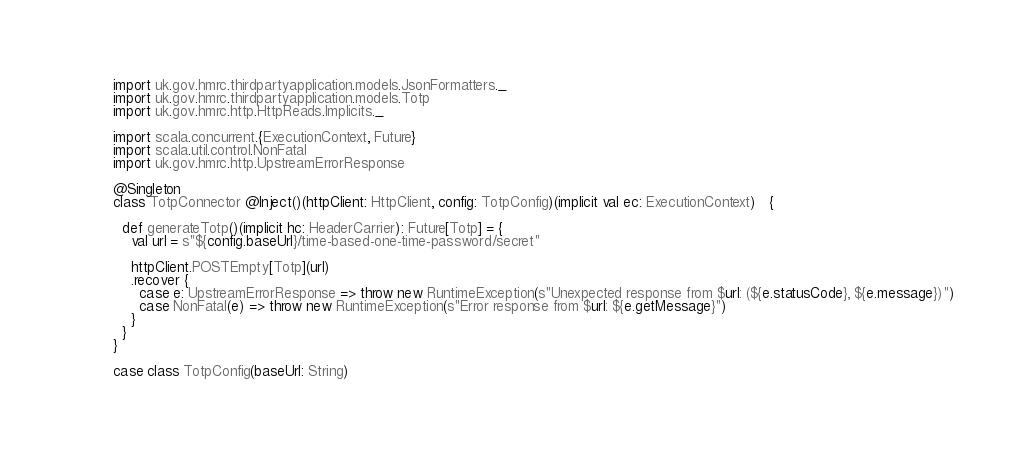<code> <loc_0><loc_0><loc_500><loc_500><_Scala_>import uk.gov.hmrc.thirdpartyapplication.models.JsonFormatters._
import uk.gov.hmrc.thirdpartyapplication.models.Totp
import uk.gov.hmrc.http.HttpReads.Implicits._

import scala.concurrent.{ExecutionContext, Future}
import scala.util.control.NonFatal
import uk.gov.hmrc.http.UpstreamErrorResponse

@Singleton
class TotpConnector @Inject()(httpClient: HttpClient, config: TotpConfig)(implicit val ec: ExecutionContext)   {

  def generateTotp()(implicit hc: HeaderCarrier): Future[Totp] = {
    val url = s"${config.baseUrl}/time-based-one-time-password/secret"

    httpClient.POSTEmpty[Totp](url)
    .recover {
      case e: UpstreamErrorResponse => throw new RuntimeException(s"Unexpected response from $url: (${e.statusCode}, ${e.message})")
      case NonFatal(e) => throw new RuntimeException(s"Error response from $url: ${e.getMessage}")
    }
  }
}

case class TotpConfig(baseUrl: String)
</code> 